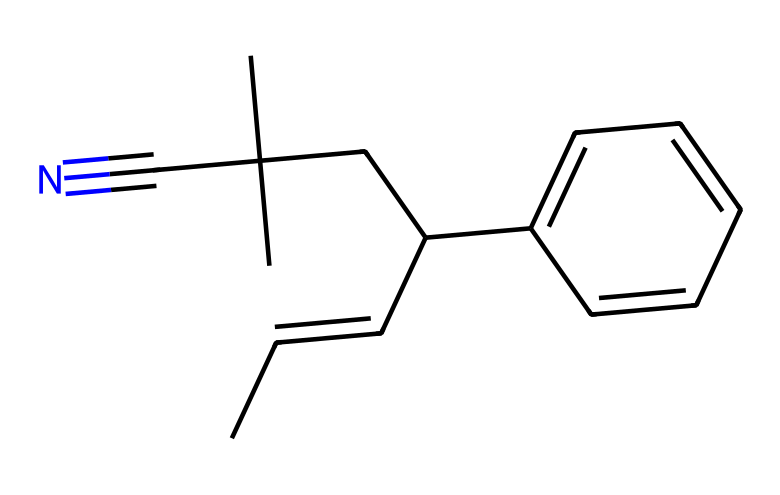What is the total number of carbon atoms in the structure? By examining the SMILES representation, we count all the "C" (carbon) atoms present. The given structure contains 12 carbon atoms.
Answer: 12 How many nitrogen atoms are in this compound? In the SMILES notation, we identify the nitrogen atom represented by "N". There is only one nitrogen atom present in the structure.
Answer: 1 What type of polymer is acrylonitrile butadiene styrene (ABS)? ABS is classified as a thermoplastic due to its ability to be melted and remolded upon heating, which is characteristic of thermoplastics.
Answer: thermoplastic Which functional group is indicated by the "#N" in the structure? The "#N" indicates a nitrile group, characterized by the triple bond between carbon and nitrogen. This functional group contributes to the properties of the polymer.
Answer: nitrile What property does the butadiene segment impart to ABS? The butadiene segment is known for enhancing elasticity and toughness within the polymer matrix, making the resulting plastic more durable and flexible.
Answer: elasticity What type of chemical bonds are primarily present in ABS plastic? The primary chemical bonds in ABS plastic include covalent bonds between carbon and nitrogen atoms, and also sigma bonds between carbon atoms, which are typical for synthetic polymers.
Answer: covalent bonds How does the presence of styrene affect the properties of ABS? Styrene contributes to the rigidity and strength of the ABS polymer, making it suitable for applications that require both toughness and structural integrity.
Answer: rigidity 